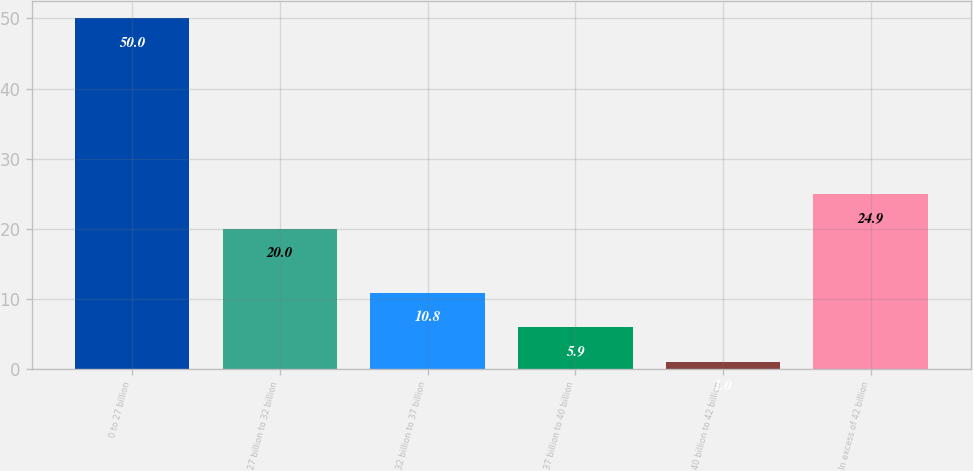<chart> <loc_0><loc_0><loc_500><loc_500><bar_chart><fcel>0 to 27 billion<fcel>27 billion to 32 billion<fcel>32 billion to 37 billion<fcel>37 billion to 40 billion<fcel>40 billion to 42 billion<fcel>In excess of 42 billion<nl><fcel>50<fcel>20<fcel>10.8<fcel>5.9<fcel>1<fcel>24.9<nl></chart> 